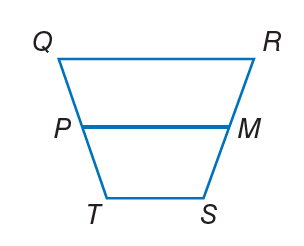Question: For trapezoid Q R S T, M and P are midpoints of the legs. If P M = 2 x, Q R = 3 x, and T S = 10, find P M.
Choices:
A. 8
B. 12
C. 16
D. 20
Answer with the letter. Answer: D Question: For trapezoid Q R S T, M and P are midpoints of the legs. If Q R = 16, P M = 12, and T S = 4 x, find x.
Choices:
A. 2
B. 8
C. 12
D. 16
Answer with the letter. Answer: A Question: For trapezoid Q R S T, M and P are midpoints of the legs. If T S = 2 x + 2, Q R = 5 x + 3, and P M = 13, find T S.
Choices:
A. 4
B. 8
C. 12
D. 20
Answer with the letter. Answer: B Question: For trapezoid Q R S T, M and P are midpoints of the legs. If T S = 2 x, P M = 20, and Q R = 6 x, find x.
Choices:
A. 5
B. 10
C. 15
D. 30
Answer with the letter. Answer: A 